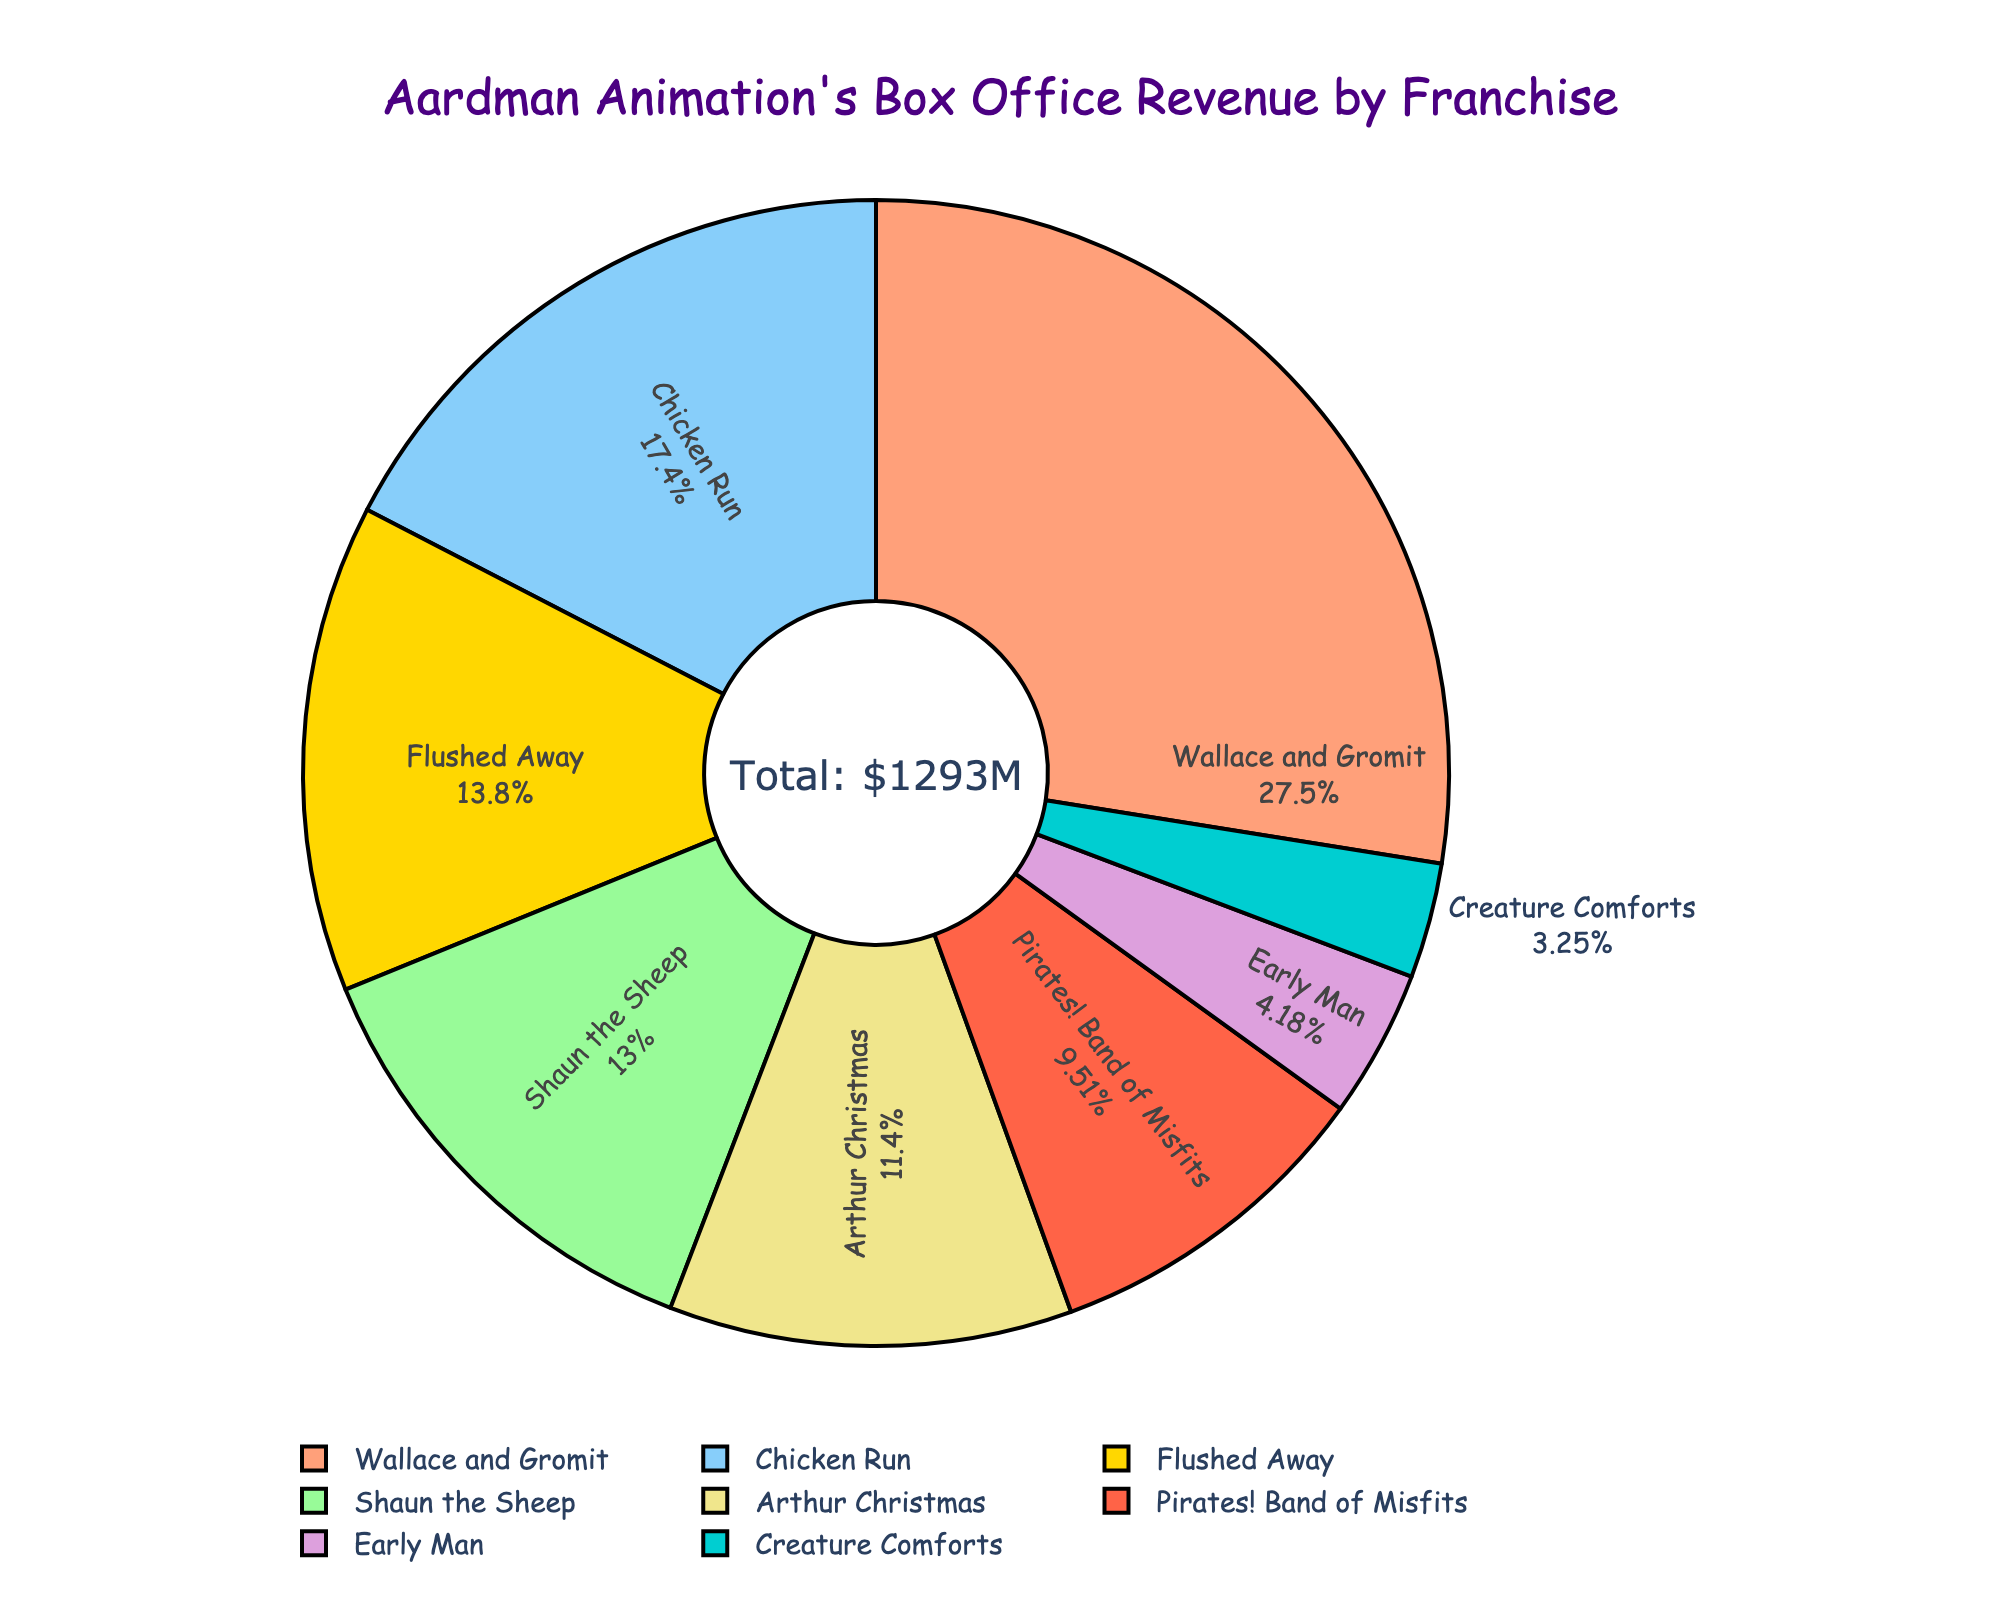What's the largest franchise by box office revenue? To determine which franchise has the largest box office revenue, look for the segment in the pie chart that has the largest size and corresponding label.
Answer: Wallace and Gromit Which franchise has the smallest box office revenue? Identify the smallest segment in the pie chart and check the corresponding label.
Answer: Creature Comforts What is the total box office revenue of Wallace and Gromit and Chicken Run combined? Locate the segments for Wallace and Gromit and Chicken Run in the pie chart. Sum their revenues: 356M + 225M = 581M.
Answer: 581M By what percentage does Shaun the Sheep's revenue exceed Early Man's revenue? First, identify the revenues: Shaun the Sheep (168M), Early Man (54M). Compute the difference: 168M - 54M = 114M. Calculate the percentage: (114M / 54M) * 100 = 211.11%.
Answer: 211.11% How many franchises have revenues exceeding 150 million USD? Review each segment of the pie chart and count how many have revenues over 150M. These are Wallace and Gromit (356M), Chicken Run (225M), Flushed Away (178M), and Shaun the Sheep (168M).
Answer: 4 What color represents the Arthur Christmas franchise? Find the segment labeled "Arthur Christmas" and note its color.
Answer: Yellow Is the sum of revenues of lesser-known franchises (Early Man, Pirates! Band of Misfits, Creature Comforts) more than that of Flushed Away? First, sum the revenues of the lesser-known franchises: 54M (Early Man) + 123M (Pirates! Band of Misfits) + 42M (Creature Comforts) = 219M. Compare this with Flushed Away's revenue of 178M.
Answer: Yes What is the percentage share of Flushed Away in the total box office revenue? Calculate Flushed Away's revenue percentage: (178M / (356M + 168M + 225M + 54M + 147M + 178M + 123M + 42M)) * 100. The total is 1293M, so (178M / 1293M) * 100 ≈ 13.77%.
Answer: 13.77% Which franchise comes immediately after Wallace and Gromit in terms of revenue size? Find the segment immediately smaller than Wallace and Gromit’s and check its label. This is Chicken Run with 225M.
Answer: Chicken Run What is the combined percentage of total revenue for Shaun the Sheep and Arthur Christmas? Calculate the individual percentages, then add them up: Shaun the Sheep = (168M/1293M) * 100 ≈ 12.99%. Arthur Christmas = (147M/1293M) * 100 ≈ 11.37%. Combined percentage ≈ 12.99% + 11.37% = 24.36%.
Answer: 24.36% 